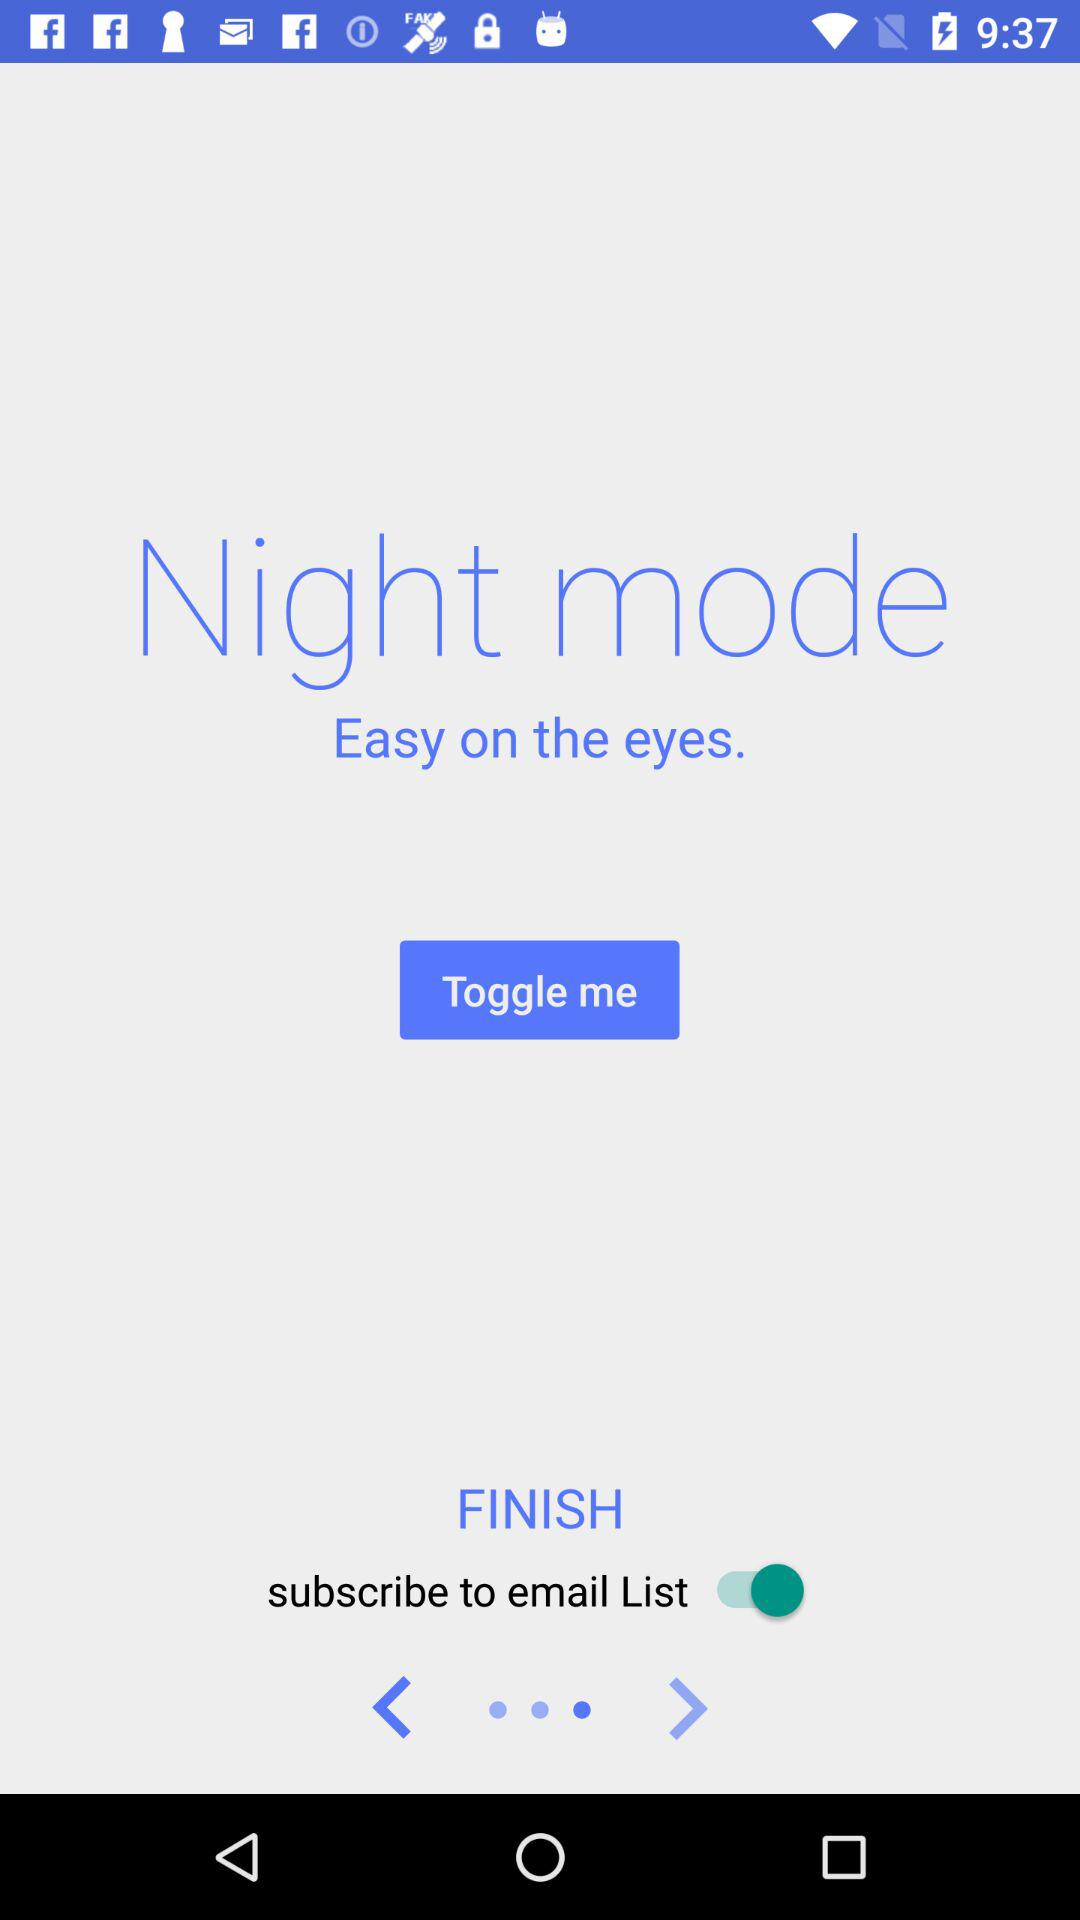What is the status of "subscribe to email List"? The status is "on". 